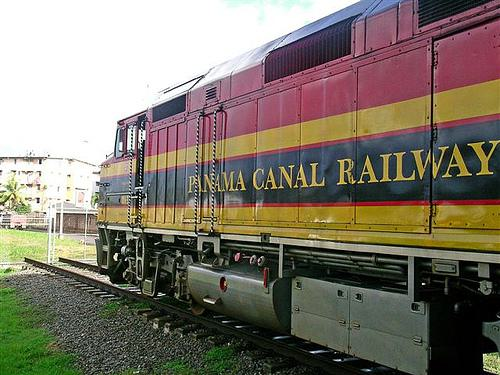What does the text on the train indicate? The text on the side of the train reads 'Panama Canal Railway,' which implies that this train is part of the railway system that runs parallel to the famous Panama Canal, often used for transporting goods and passengers across the isthmus of Panama. 